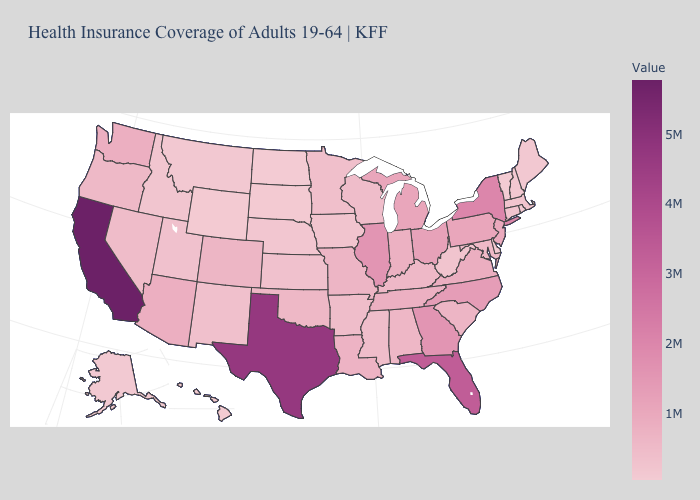Does Washington have the highest value in the West?
Concise answer only. No. Which states have the highest value in the USA?
Give a very brief answer. California. Does California have the highest value in the USA?
Keep it brief. Yes. Which states have the lowest value in the USA?
Give a very brief answer. Vermont. Is the legend a continuous bar?
Give a very brief answer. Yes. 